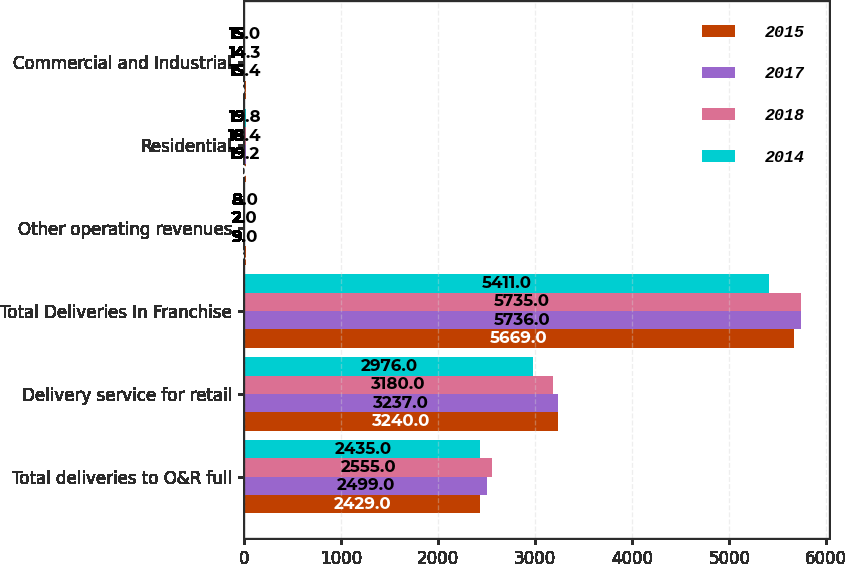Convert chart to OTSL. <chart><loc_0><loc_0><loc_500><loc_500><stacked_bar_chart><ecel><fcel>Total deliveries to O&R full<fcel>Delivery service for retail<fcel>Total Deliveries In Franchise<fcel>Other operating revenues<fcel>Residential<fcel>Commercial and Industrial<nl><fcel>2015<fcel>2429<fcel>3240<fcel>5669<fcel>18<fcel>20.3<fcel>16.8<nl><fcel>2017<fcel>2499<fcel>3237<fcel>5736<fcel>9<fcel>19.2<fcel>15.4<nl><fcel>2018<fcel>2555<fcel>3180<fcel>5735<fcel>2<fcel>18.4<fcel>14.3<nl><fcel>2014<fcel>2435<fcel>2976<fcel>5411<fcel>8<fcel>19.8<fcel>15<nl></chart> 